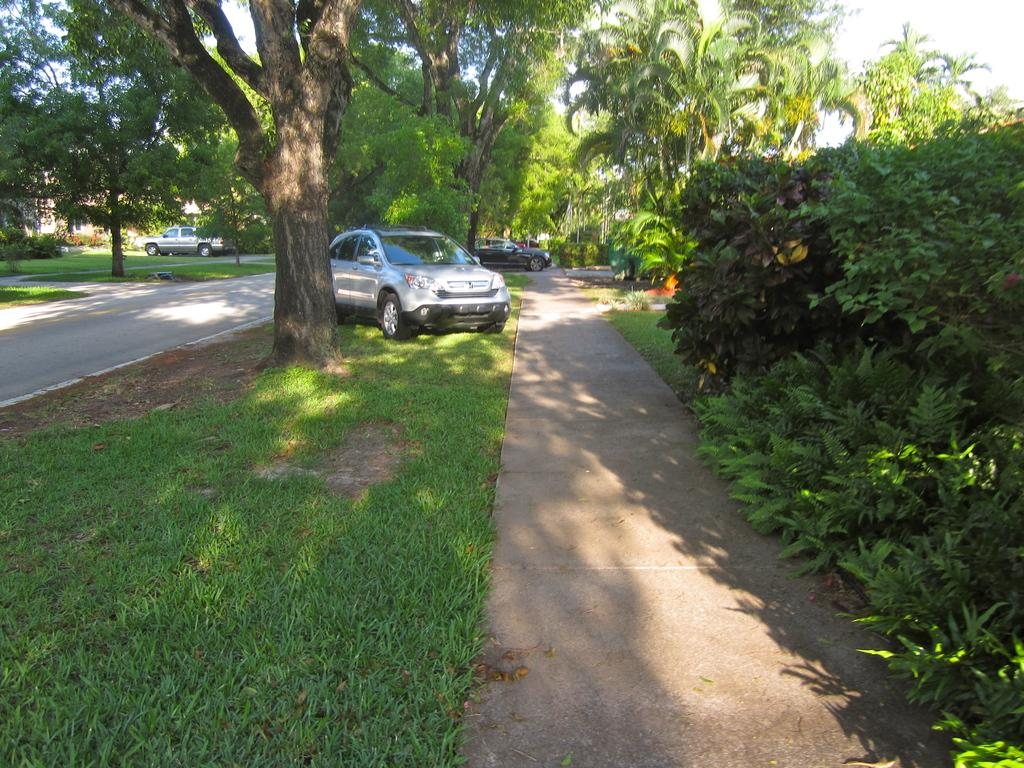What types of objects are present in the image? There are vehicles and plants in the image. What type of vegetation can be seen in the image? There is grass in the image. What is visible in the background of the image? There are trees in the background of the image. Can you see any marks on the vehicles in the image? There is no mention of marks on the vehicles in the provided facts, so we cannot determine if any marks are present. 